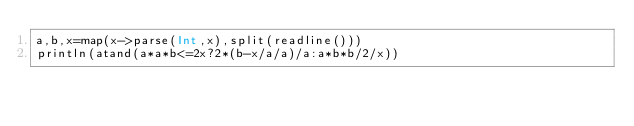<code> <loc_0><loc_0><loc_500><loc_500><_Julia_>a,b,x=map(x->parse(Int,x),split(readline()))
println(atand(a*a*b<=2x?2*(b-x/a/a)/a:a*b*b/2/x))
</code> 